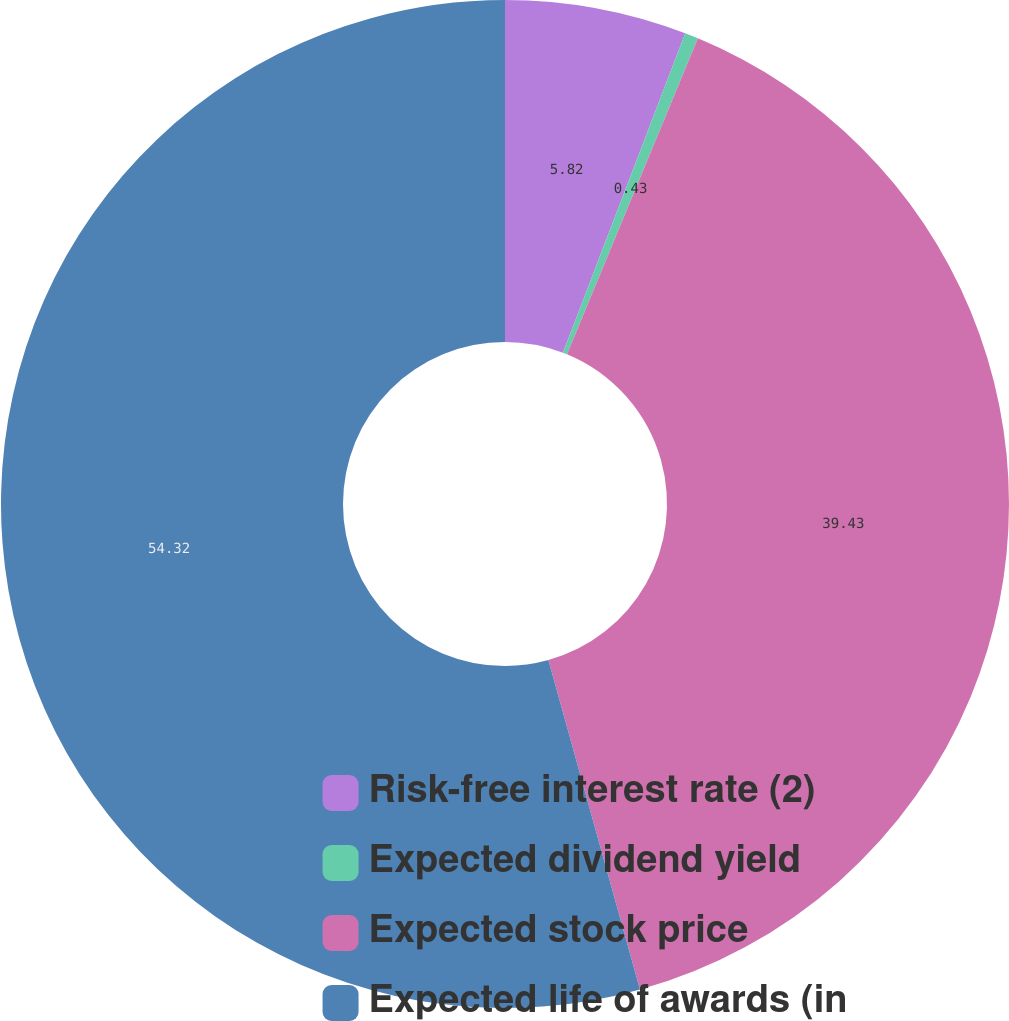<chart> <loc_0><loc_0><loc_500><loc_500><pie_chart><fcel>Risk-free interest rate (2)<fcel>Expected dividend yield<fcel>Expected stock price<fcel>Expected life of awards (in<nl><fcel>5.82%<fcel>0.43%<fcel>39.43%<fcel>54.31%<nl></chart> 